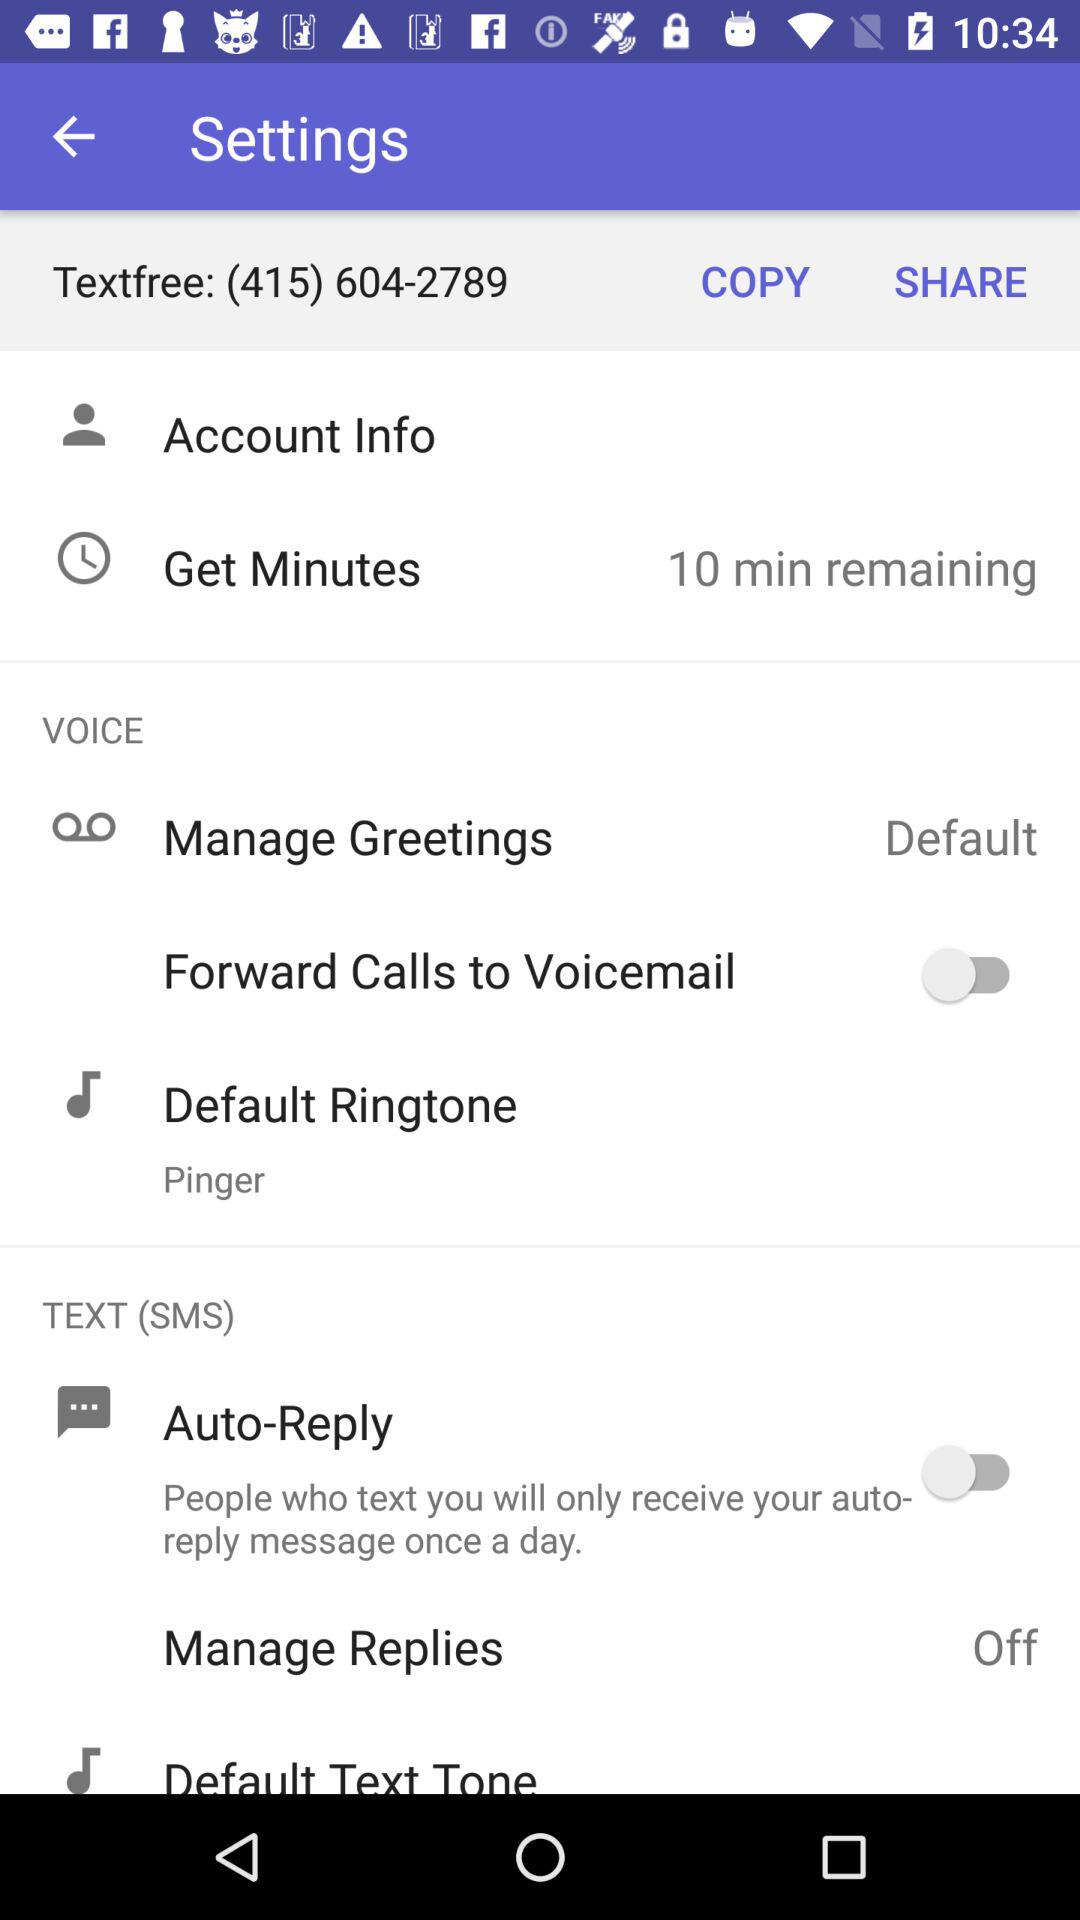What is the setting for the default ringtone? The setting for the default ringtone is "Pinger". 